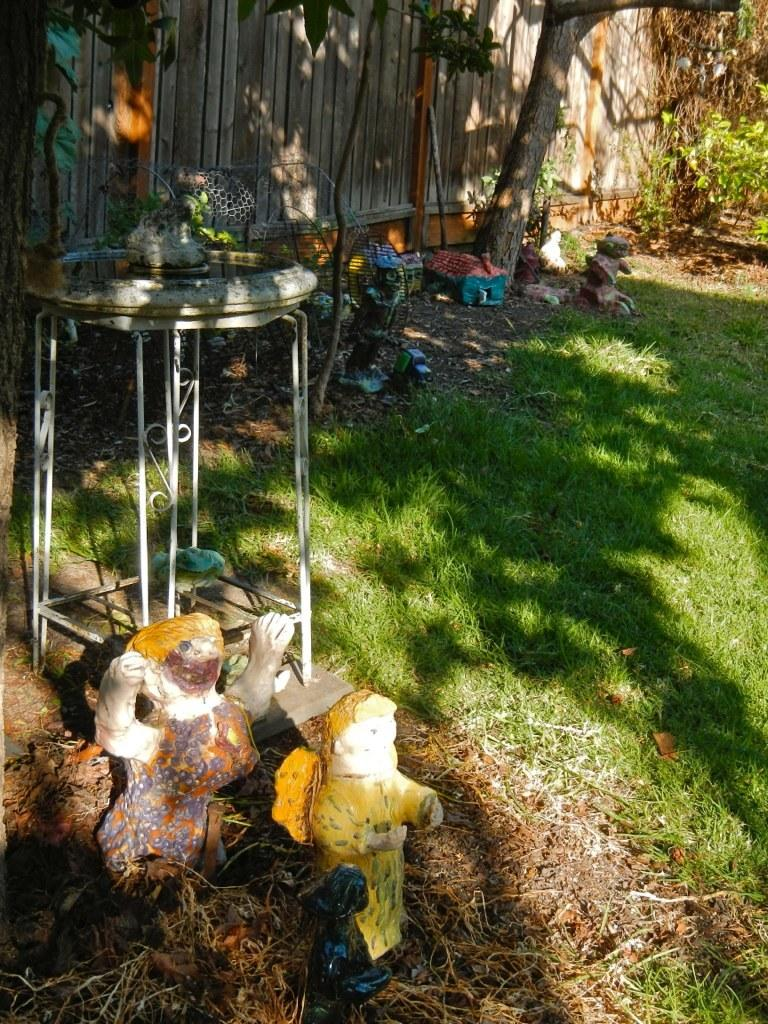What can be seen in the foreground of the image? There are statues, grass, and a table in the foreground of the image. What type of surface is visible in the foreground? The grass in the foreground suggests that the surface is a lawn or grassy area. What can be seen in the background of the image? There is a wooden wall and trees in the background of the image. What type of location is depicted in the image? The image is taken in a park, as indicated by the presence of statues, grass, and trees. Where are the scissors located in the image? There are no scissors present in the image. What type of spider web can be seen on the wooden wall in the image? There is no spider web, including a cobweb, present on the wooden wall in the image. 